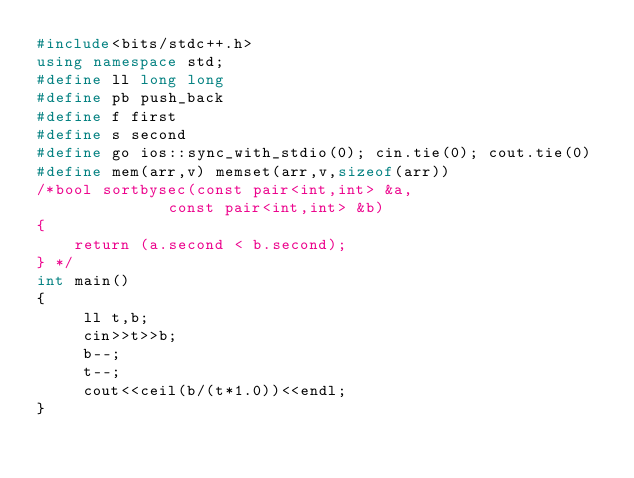<code> <loc_0><loc_0><loc_500><loc_500><_C++_>#include<bits/stdc++.h>
using namespace std;
#define ll long long
#define pb push_back
#define f first
#define s second
#define go ios::sync_with_stdio(0); cin.tie(0); cout.tie(0)
#define mem(arr,v) memset(arr,v,sizeof(arr))
/*bool sortbysec(const pair<int,int> &a,
              const pair<int,int> &b)
{
    return (a.second < b.second);
} */
int main()
{
     ll t,b;
     cin>>t>>b;
     b--;
     t--;
     cout<<ceil(b/(t*1.0))<<endl;
}
</code> 